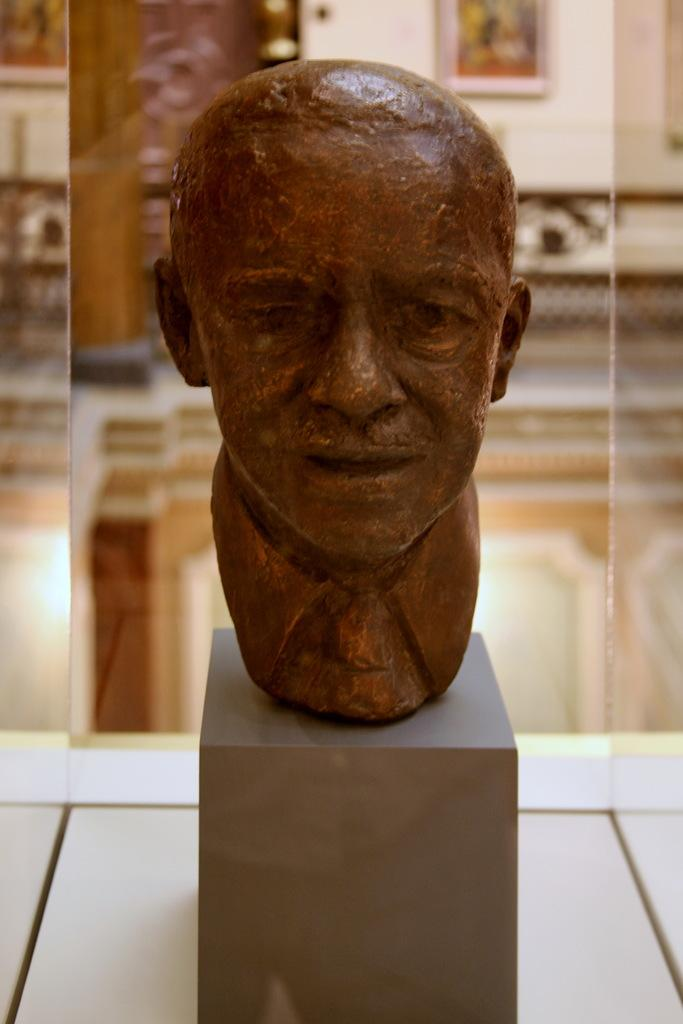What is the main object in the image? There is an idol in the image. How is the idol positioned in the image? The idol is on a stand. Where is the stand located? The stand is on a table. How is the idol protected or enclosed? The idol is kept in a glass box. What can be seen in the background of the image? There is a wall in the background of the image, and frames are attached to the wall. What type of shirt is the idol wearing in the image? The idol is not a person and therefore does not wear a shirt. The idol is a statue or representation of a deity or figure, and it is made of materials like stone, metal, or wood. 